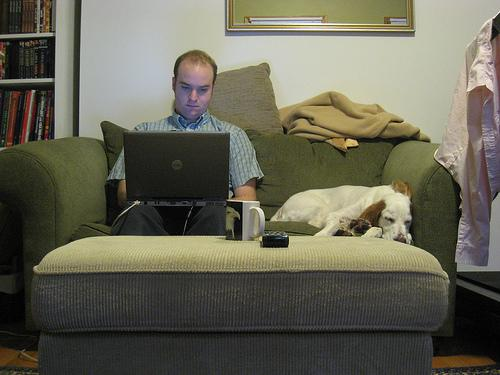Write a short and casual sentence about what's happening in this image. A dude is just chilling on his couch, browsing the web on his laptop. What is the central human figure in the image engaged in? Describe it in a brief sentence. A man on a green sofa is engrossed in his laptop computer. In one sentence, describe the overall atmosphere of the image. A cozy and busy scene of a man working on his laptop on a couch, accompanied by his dog. Write a poetic sentence describing the main subject in the image. An absorbed man lounges upon a couch green, engrossed in his laptop's luminous screen. Detail the primary scene of the image in a concise manner. Man on couch working on laptop, surrounded by various objects. Provide a description of the main subject's attire. The man is wearing a plaid shirt and gray pants while sitting on the couch. What is the central focus of the image? Describe it briefly. The main focus is a man using a laptop computer while sitting on a couch. Mention the animal in the image and describe its current activity. A large white dog with brown ears is lying on the couch and sleeping. Mention the primary individual visible in this image and describe their activity. A man is sitting on a green couch and working on a gray laptop computer. Present the main action in the image in an informal tone. A guy lounging on a sofa, busy with his laptop. 